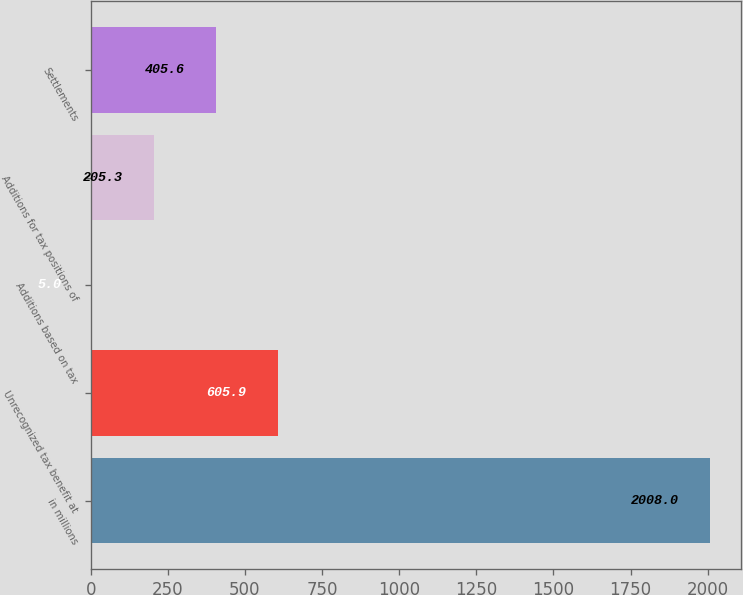Convert chart. <chart><loc_0><loc_0><loc_500><loc_500><bar_chart><fcel>in millions<fcel>Unrecognized tax benefit at<fcel>Additions based on tax<fcel>Additions for tax positions of<fcel>Settlements<nl><fcel>2008<fcel>605.9<fcel>5<fcel>205.3<fcel>405.6<nl></chart> 